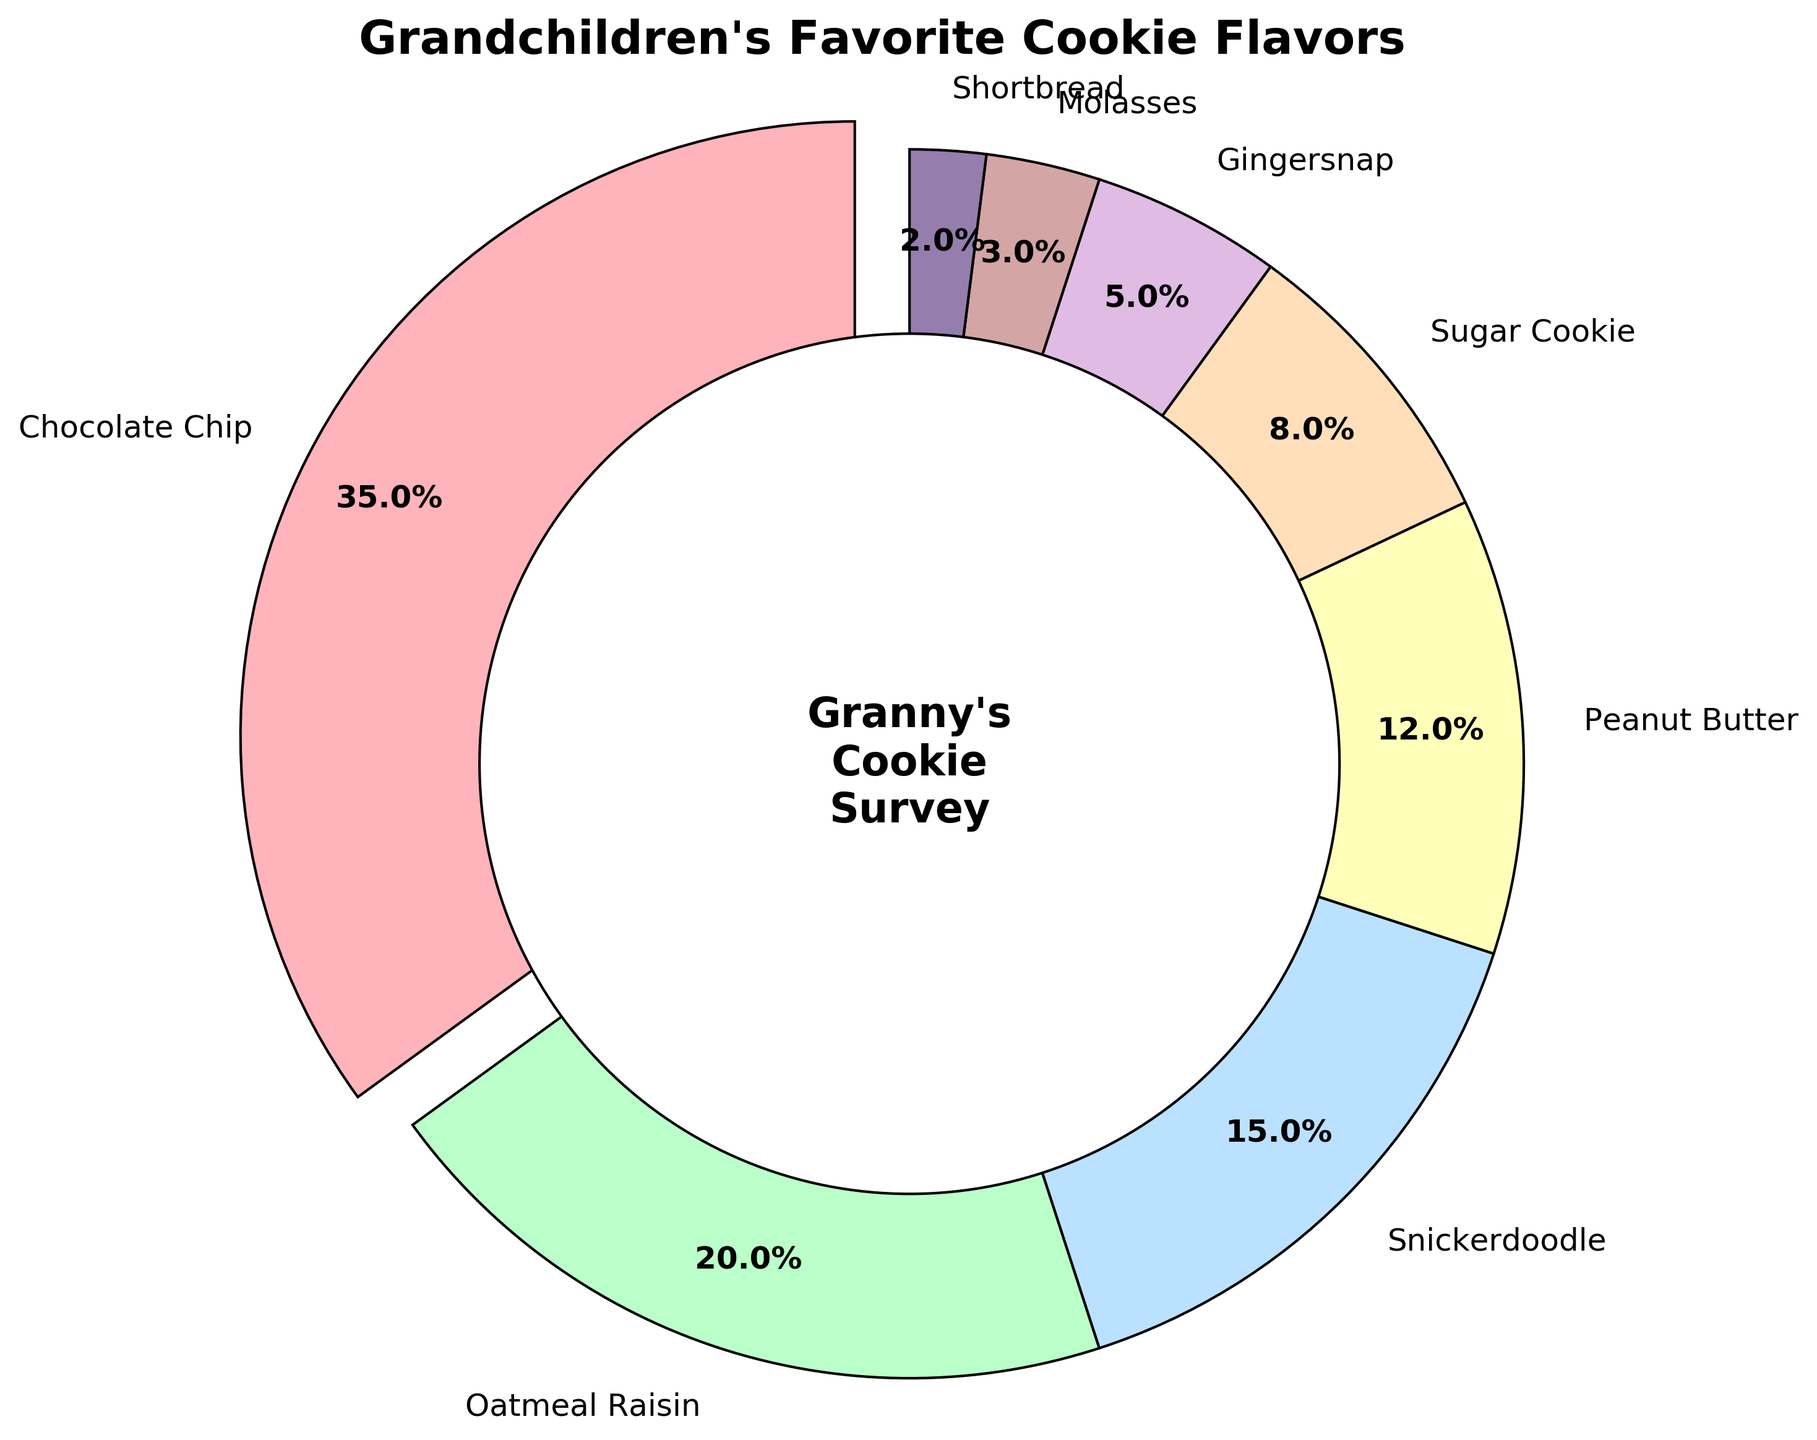How many cookie flavors have a percentage greater than 10%? There are four flavors with a percentage greater than 10%: Chocolate Chip (35%), Oatmeal Raisin (20%), Snickerdoodle (15%), and Peanut Butter (12%).
Answer: 4 Which cookie flavor has the highest percentage among the grandchildren? The pie chart shows that Chocolate Chip has the largest slice, indicating it has the highest percentage of 35%.
Answer: Chocolate Chip Which cookie flavor has the smallest percentage? The smallest slice of the pie chart indicates that Shortbread has the smallest percentage of 2%.
Answer: Shortbread What is the total percentage of all flavors that have a percentage less than or equal to 10%? Add the percentages of Sugar Cookie (8%), Gingersnap (5%), Molasses (3%), and Shortbread (2%). 8 + 5 + 3 + 2 = 18%.
Answer: 18% How much bigger is the percentage of Chocolate Chip compared to Peanut Butter? Subtract the percentage of Peanut Butter (12%) from the percentage of Chocolate Chip (35%). 35 - 12 = 23%.
Answer: 23% What colors are the wedges for Chocolate Chip and Oatmeal Raisin? The Chocolate Chip wedge is colored light pink and the Oatmeal Raisin wedge is light green.
Answer: Light pink and light green If you combine the percentages of Snickerdoodle and Peanut Butter, what is the resulting percentage? Add the percentages of Snickerdoodle (15%) and Peanut Butter (12%). 15 + 12 = 27%.
Answer: 27% Which color represents the Sugar Cookie flavor on the pie chart? The wedge for Sugar Cookie is colored a pale yellow.
Answer: Pale yellow What is the difference in percentage between the highest and lowest favored cookie flavors? Subtract the percentage of the lowest favored flavor, Shortbread (2%), from the highest, Chocolate Chip (35%). 35 - 2 = 33%.
Answer: 33% How many cookie flavors have percentages between 5% and 20%? The flavors with percentages between 5% and 20% are Oatmeal Raisin (20%), Snickerdoodle (15%), and Peanut Butter (12%), and Gingersnap (5%).
Answer: 4 